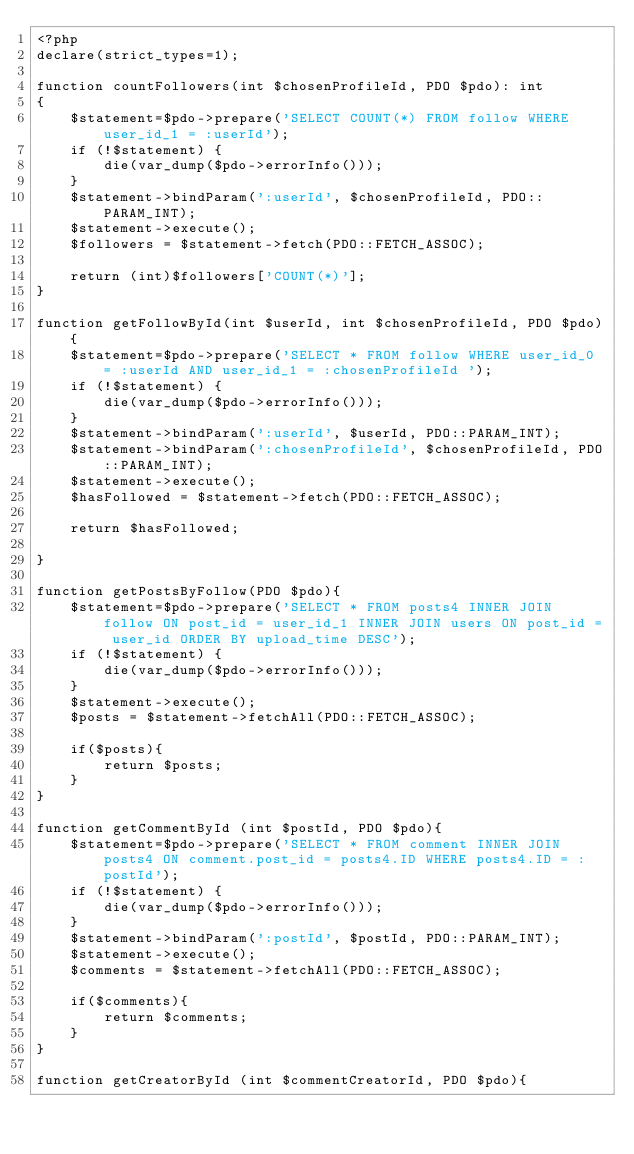<code> <loc_0><loc_0><loc_500><loc_500><_PHP_><?php
declare(strict_types=1);

function countFollowers(int $chosenProfileId, PDO $pdo): int
{
    $statement=$pdo->prepare('SELECT COUNT(*) FROM follow WHERE user_id_1 = :userId');
    if (!$statement) {
        die(var_dump($pdo->errorInfo()));
    }
    $statement->bindParam(':userId', $chosenProfileId, PDO::PARAM_INT);
    $statement->execute();
    $followers = $statement->fetch(PDO::FETCH_ASSOC);

    return (int)$followers['COUNT(*)'];
}

function getFollowById(int $userId, int $chosenProfileId, PDO $pdo){
    $statement=$pdo->prepare('SELECT * FROM follow WHERE user_id_0 = :userId AND user_id_1 = :chosenProfileId ');
    if (!$statement) {
        die(var_dump($pdo->errorInfo()));
    }
    $statement->bindParam(':userId', $userId, PDO::PARAM_INT);
    $statement->bindParam(':chosenProfileId', $chosenProfileId, PDO::PARAM_INT);
    $statement->execute();
    $hasFollowed = $statement->fetch(PDO::FETCH_ASSOC);

    return $hasFollowed;

}

function getPostsByFollow(PDO $pdo){
    $statement=$pdo->prepare('SELECT * FROM posts4 INNER JOIN follow ON post_id = user_id_1 INNER JOIN users ON post_id = user_id ORDER BY upload_time DESC');
    if (!$statement) {
        die(var_dump($pdo->errorInfo()));
    }
    $statement->execute();
    $posts = $statement->fetchAll(PDO::FETCH_ASSOC);

    if($posts){
        return $posts;
    }
}

function getCommentById (int $postId, PDO $pdo){
    $statement=$pdo->prepare('SELECT * FROM comment INNER JOIN posts4 ON comment.post_id = posts4.ID WHERE posts4.ID = :postId');
    if (!$statement) {
        die(var_dump($pdo->errorInfo()));
    }
    $statement->bindParam(':postId', $postId, PDO::PARAM_INT);
    $statement->execute();
    $comments = $statement->fetchAll(PDO::FETCH_ASSOC);

    if($comments){
        return $comments;
    }
}

function getCreatorById (int $commentCreatorId, PDO $pdo){</code> 